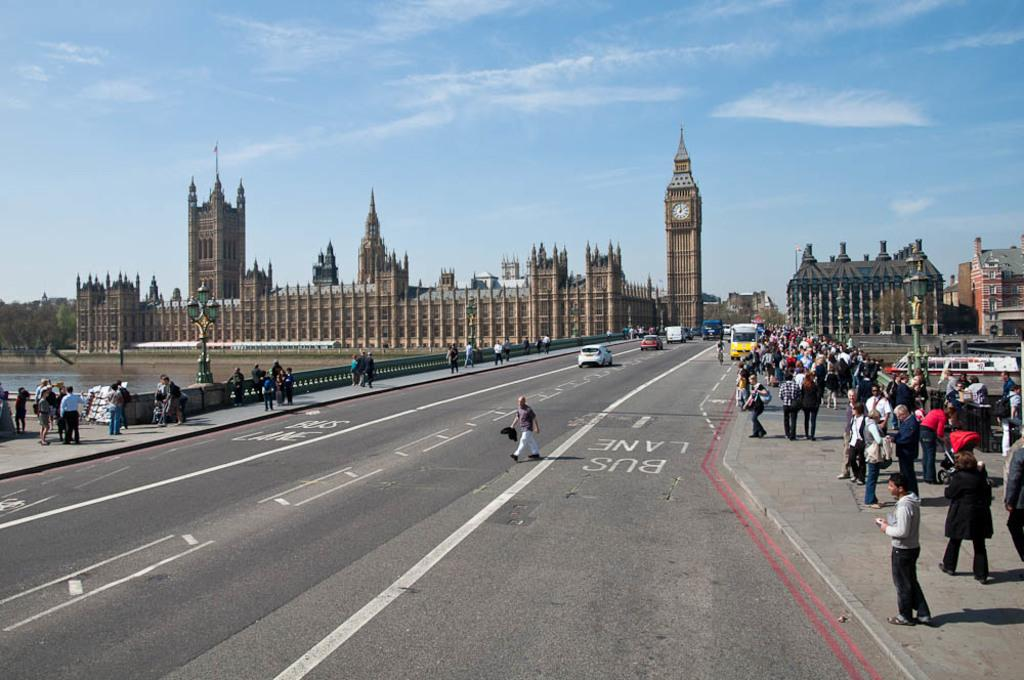What type of structures can be seen in the image? There are buildings in the image. What natural feature is present in the image? There is a lake in the image. Can you identify any living beings in the image? Yes, there are people visible in the image. What mode of transportation can be seen in the image? There are vehicles on the road in the image. What type of feather can be seen causing anger in the image? There is no feather or indication of anger present in the image. Are there any birds attacking the buildings in the image? There are no birds or attacks depicted in the image. 